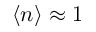Convert formula to latex. <formula><loc_0><loc_0><loc_500><loc_500>\langle n \rangle \approx 1</formula> 